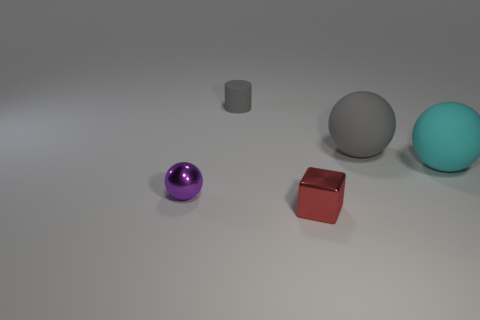Subtract all rubber balls. How many balls are left? 1 Add 3 big things. How many objects exist? 8 Subtract all gray spheres. How many spheres are left? 2 Subtract 2 balls. How many balls are left? 1 Subtract all cylinders. How many objects are left? 4 Subtract all red spheres. Subtract all green cylinders. How many spheres are left? 3 Subtract all yellow balls. How many purple blocks are left? 0 Subtract all tiny spheres. Subtract all gray rubber objects. How many objects are left? 2 Add 5 tiny red metallic blocks. How many tiny red metallic blocks are left? 6 Add 4 small purple shiny objects. How many small purple shiny objects exist? 5 